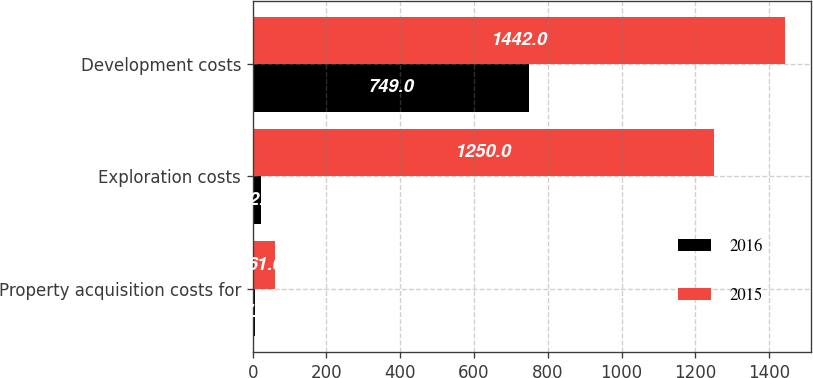Convert chart to OTSL. <chart><loc_0><loc_0><loc_500><loc_500><stacked_bar_chart><ecel><fcel>Property acquisition costs for<fcel>Exploration costs<fcel>Development costs<nl><fcel>2016<fcel>7<fcel>22<fcel>749<nl><fcel>2015<fcel>61<fcel>1250<fcel>1442<nl></chart> 